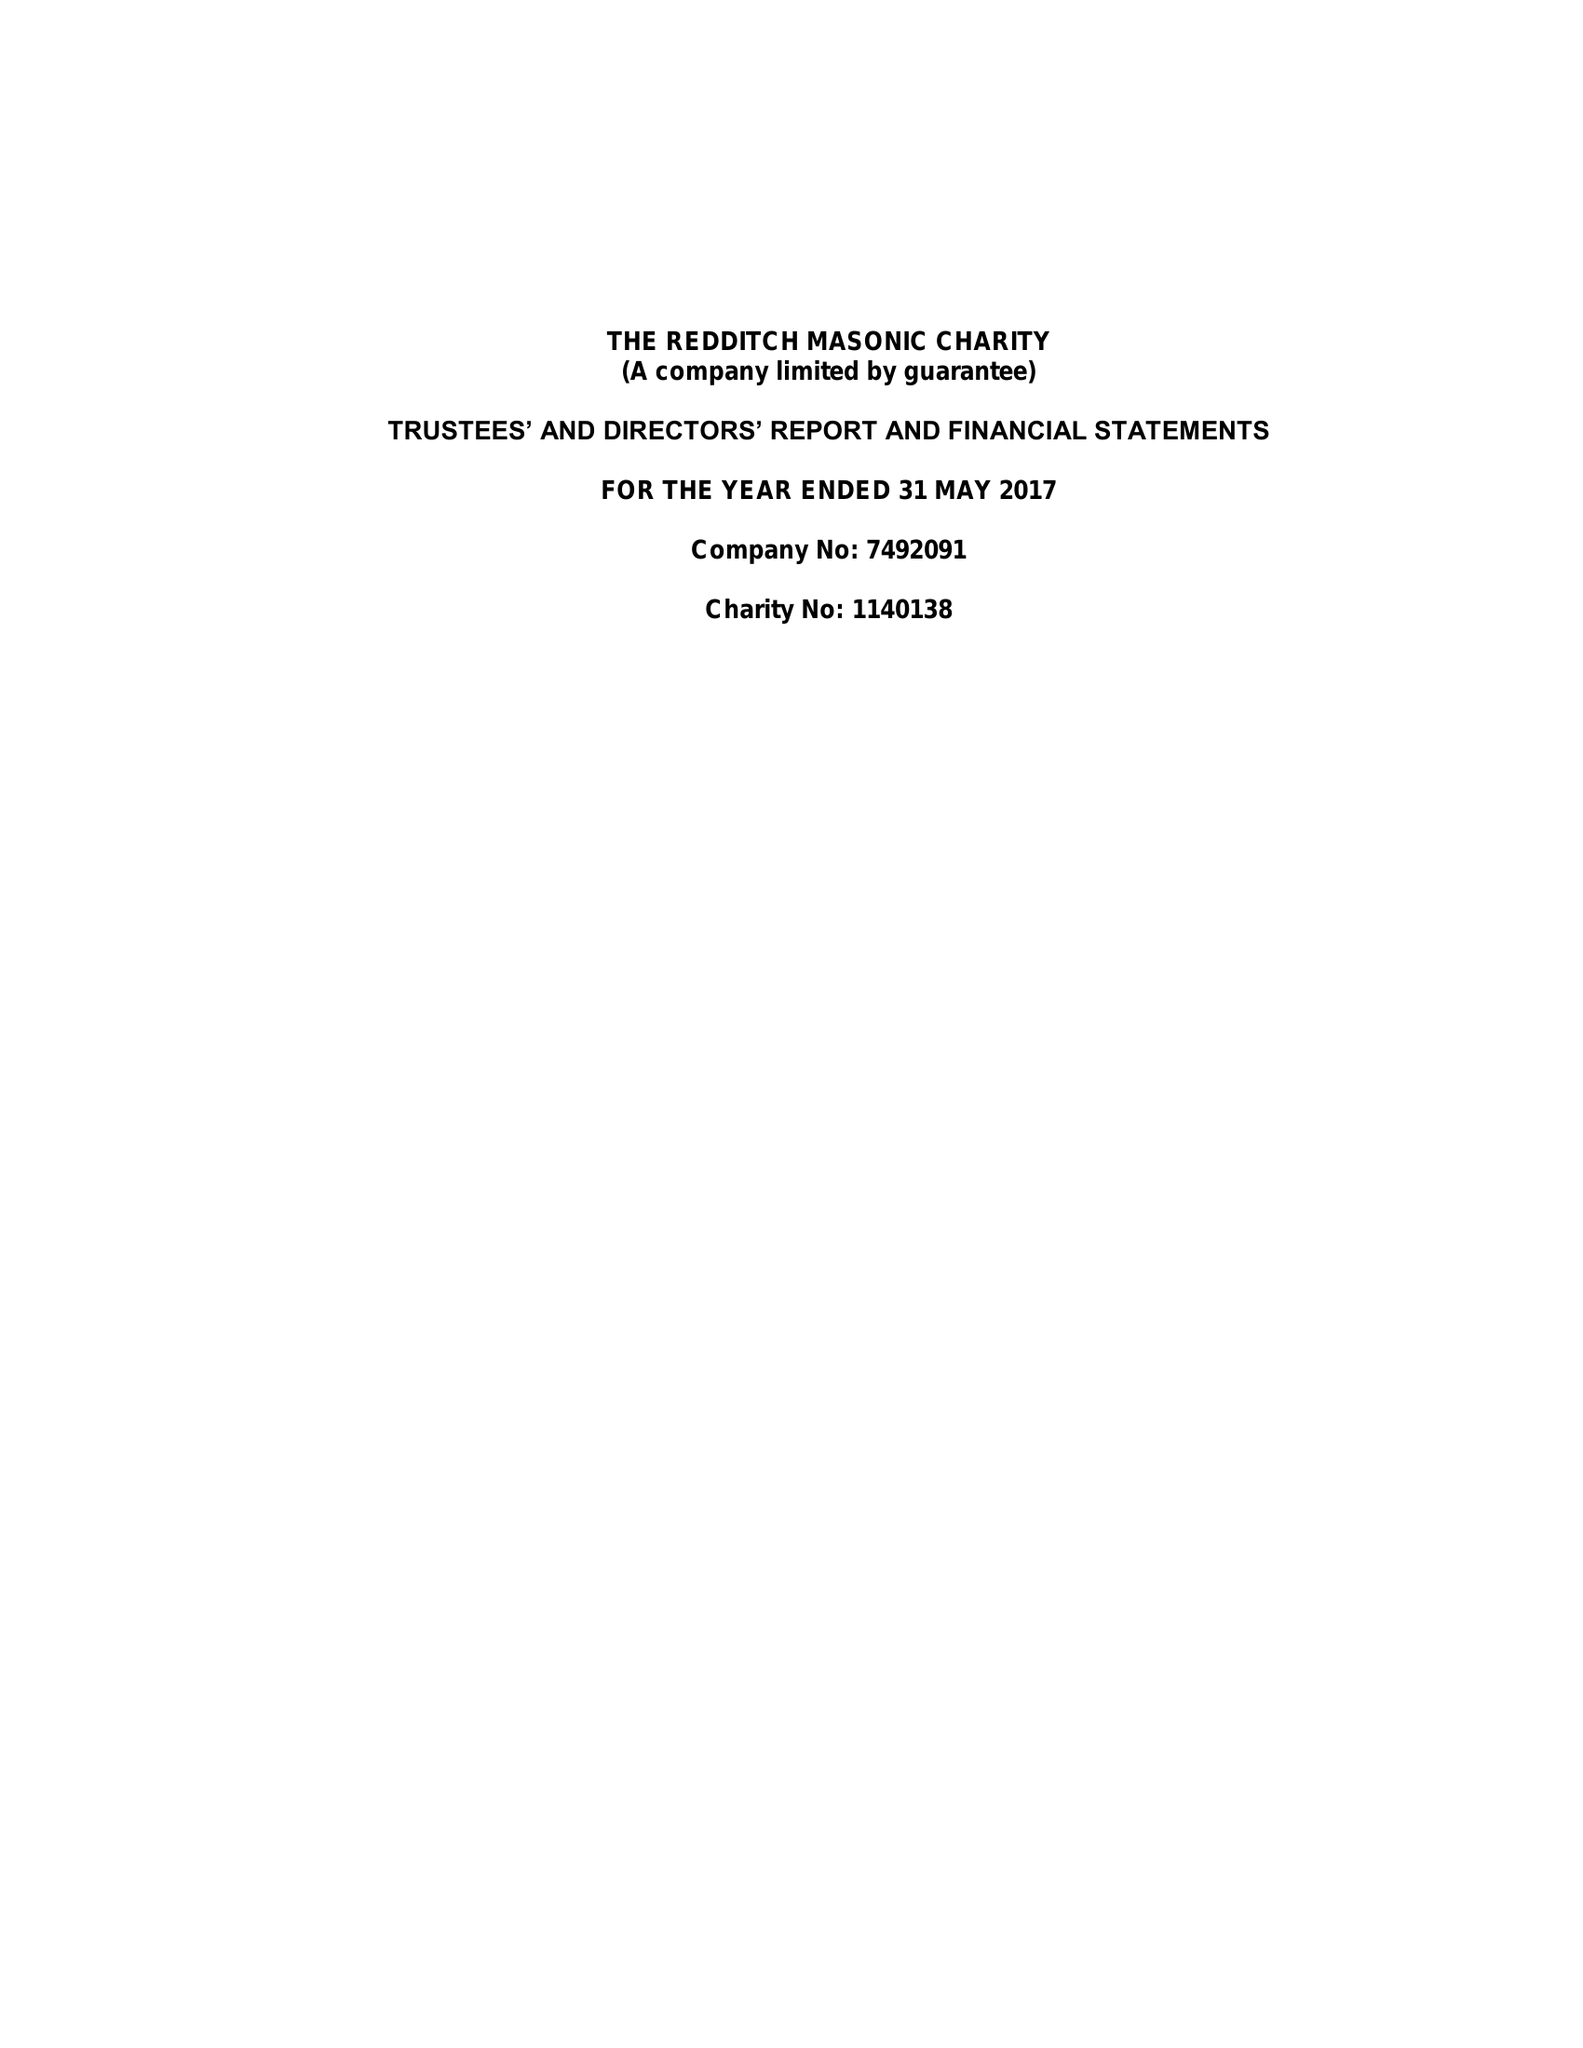What is the value for the report_date?
Answer the question using a single word or phrase. 2017-05-31 